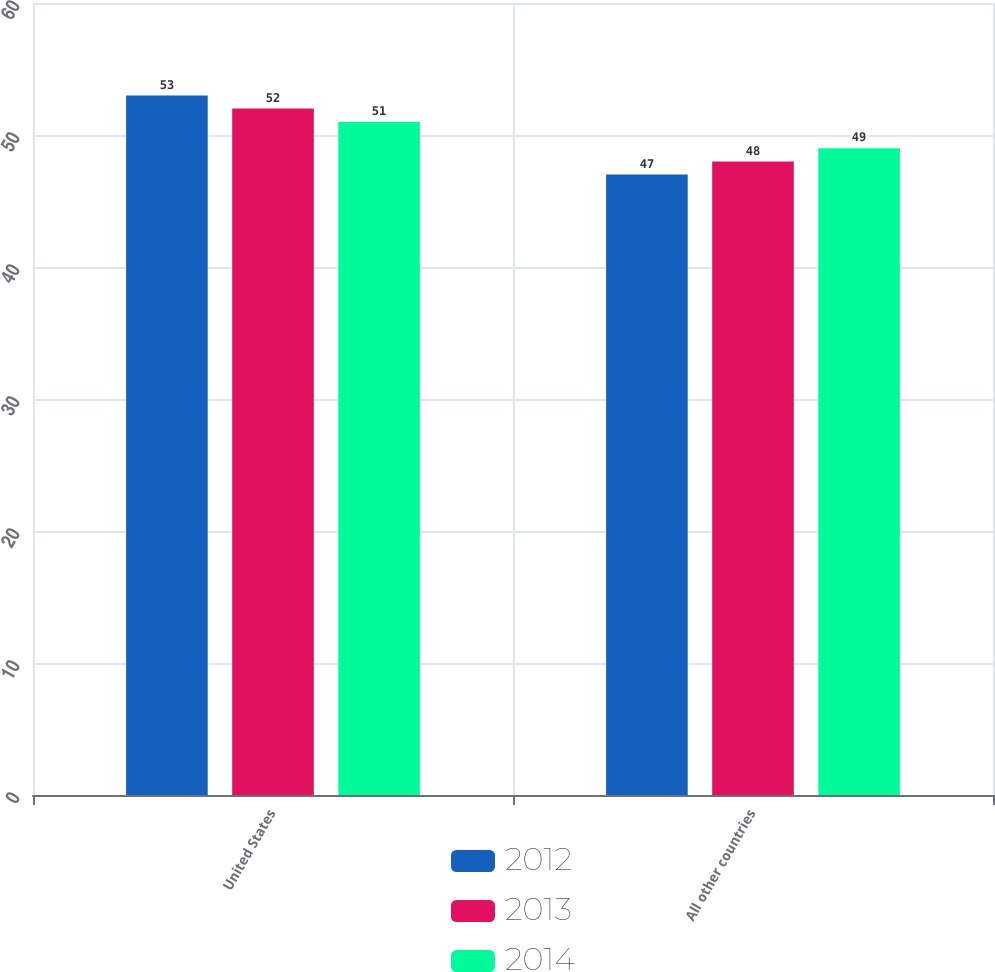Convert chart. <chart><loc_0><loc_0><loc_500><loc_500><stacked_bar_chart><ecel><fcel>United States<fcel>All other countries<nl><fcel>2012<fcel>53<fcel>47<nl><fcel>2013<fcel>52<fcel>48<nl><fcel>2014<fcel>51<fcel>49<nl></chart> 